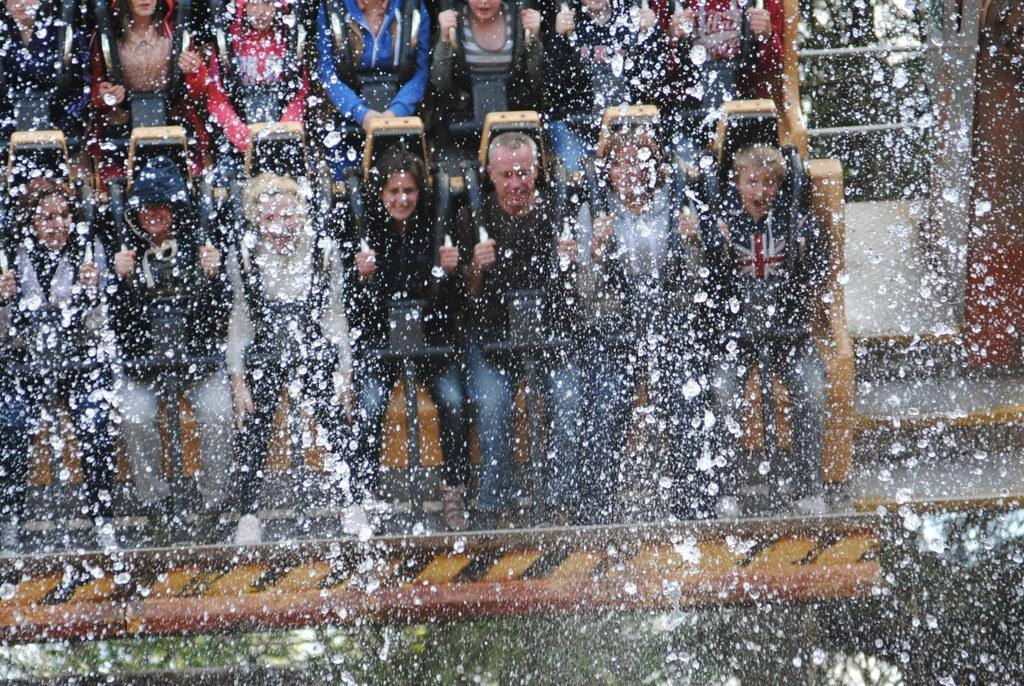How many people are in the image? There are many people in the image. What activity are the people engaged in? The people are taking a water ride. What type of needle can be seen in the image? There is no needle present in the image. What kind of shop can be seen in the background of the image? There is no shop visible in the image; it features people taking a water ride. 